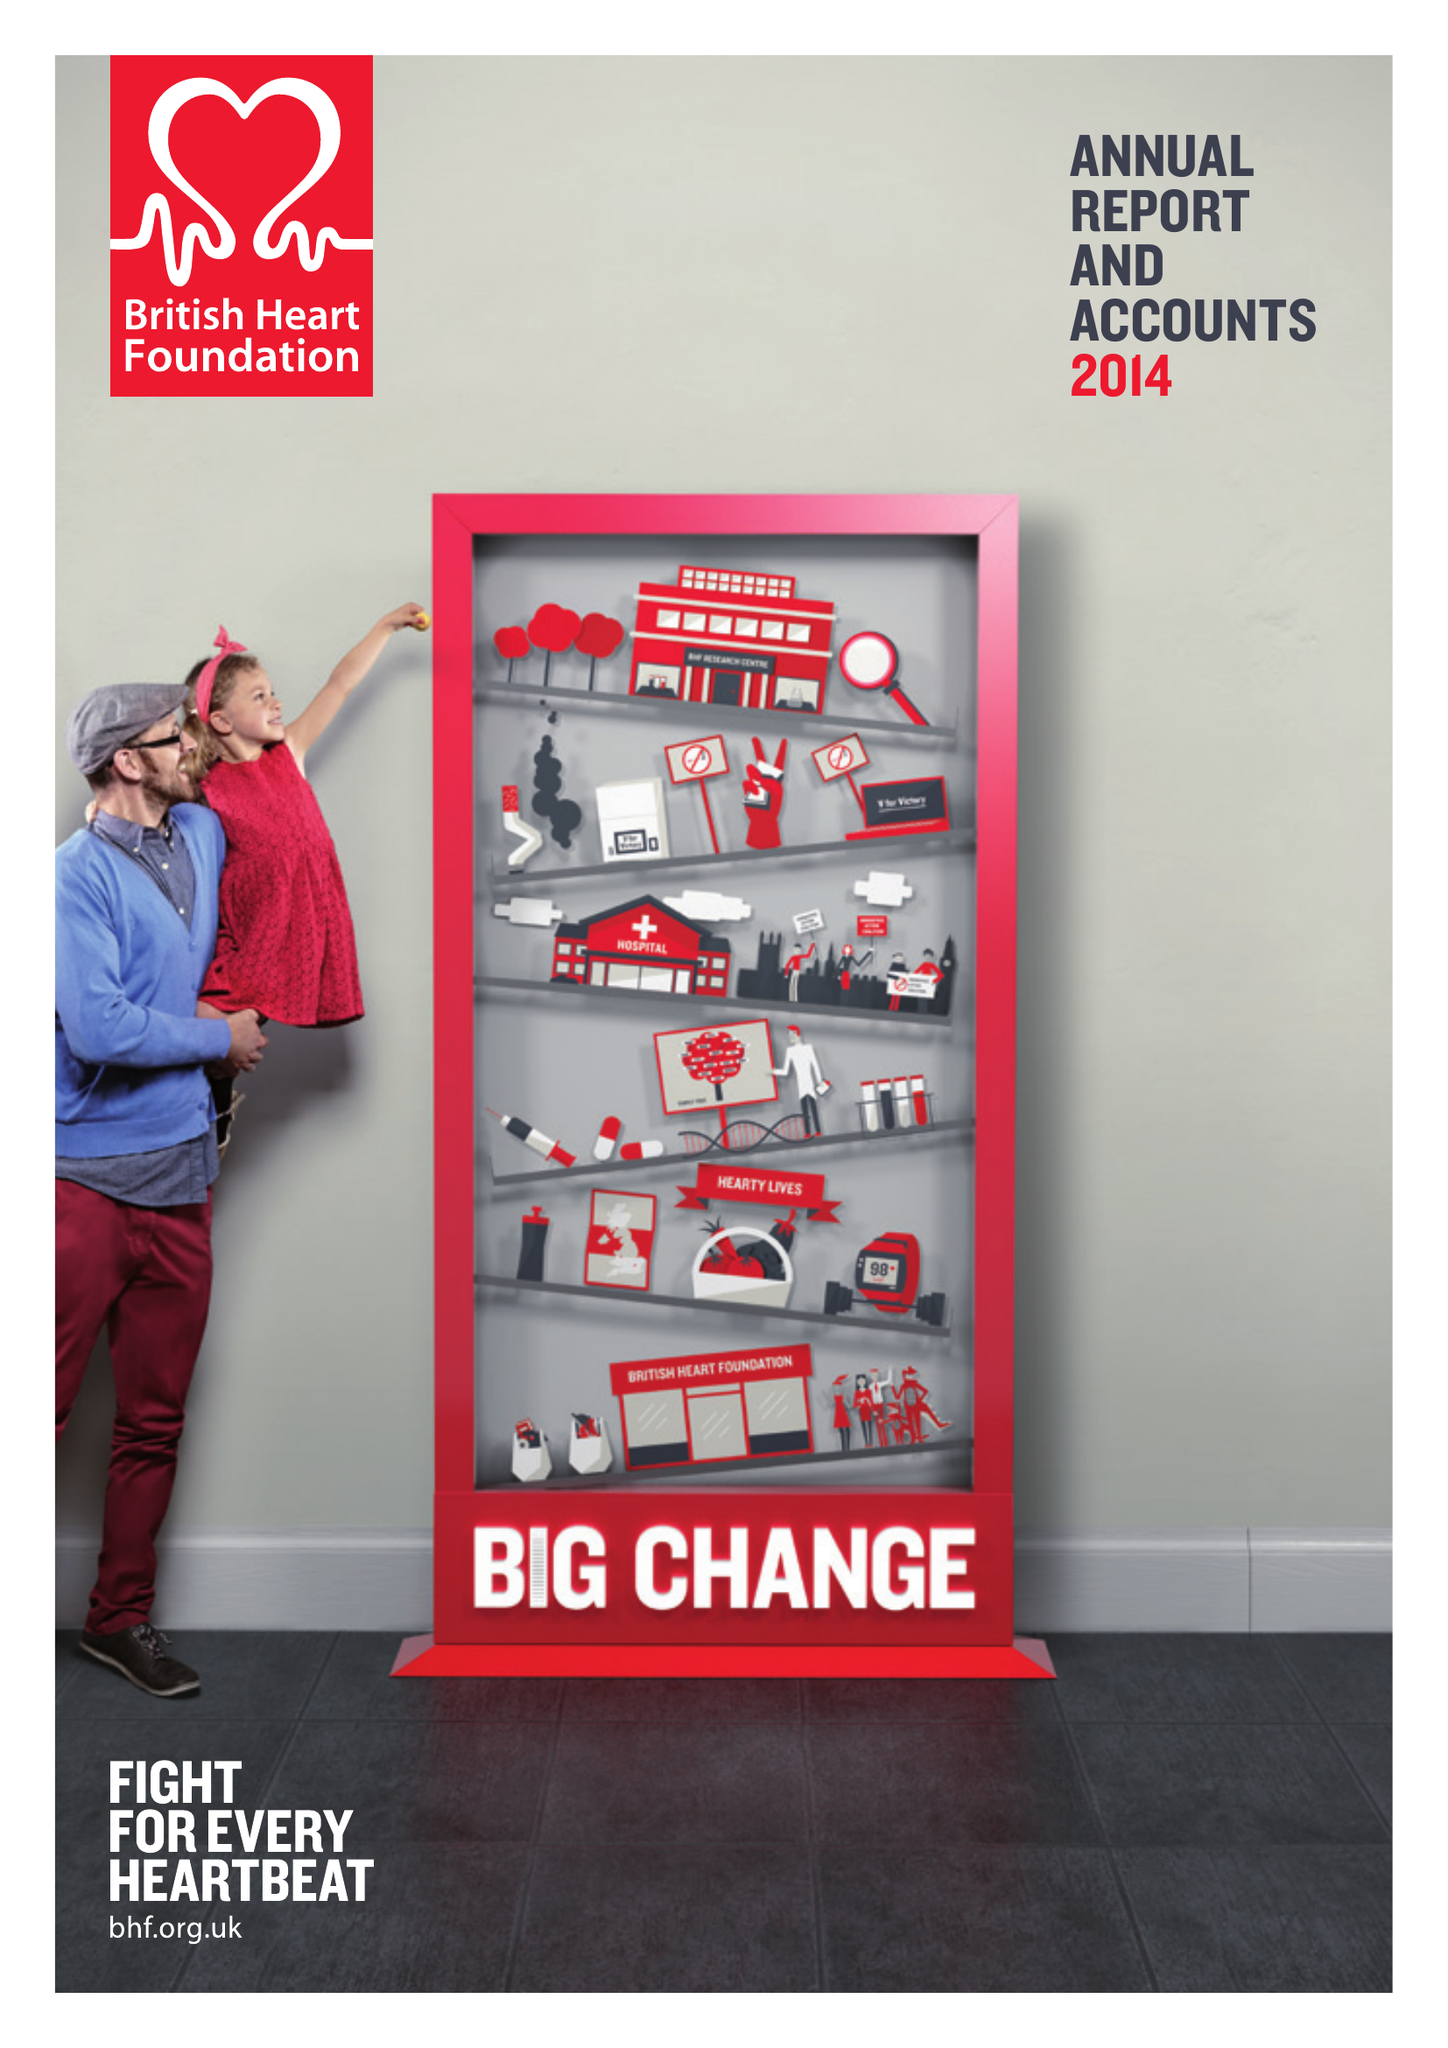What is the value for the address__post_town?
Answer the question using a single word or phrase. LONDON 